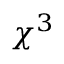Convert formula to latex. <formula><loc_0><loc_0><loc_500><loc_500>\chi ^ { 3 }</formula> 